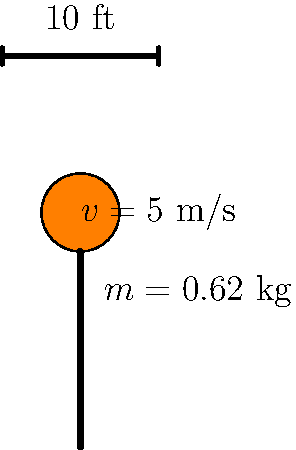During a basketball game in Evansville, a player dunks the ball straight down into the hoop. The ball has a mass of 0.62 kg and is moving at 5 m/s just before it reaches the rim. If the ball comes to a complete stop in 0.1 seconds after hitting the rim, what is the average force applied to the ball by the rim? Let's approach this step-by-step using the information given and the principles of physics:

1) First, we need to recall the relationship between force, mass, and acceleration. This is given by Newton's Second Law:

   $$F = ma$$

   where $F$ is force, $m$ is mass, and $a$ is acceleration.

2) We're given the mass of the ball: $m = 0.62$ kg

3) We need to find the acceleration. We can do this using the equation:

   $$a = \frac{\Delta v}{\Delta t}$$

   where $\Delta v$ is the change in velocity and $\Delta t$ is the time interval.

4) Initial velocity $v_i = 5$ m/s (downward)
   Final velocity $v_f = 0$ m/s (the ball stops)
   Time interval $\Delta t = 0.1$ s

5) Calculating the acceleration:

   $$a = \frac{v_f - v_i}{\Delta t} = \frac{0 - 5}{0.1} = -50 \text{ m/s}^2$$

   The negative sign indicates the acceleration is in the opposite direction of the initial velocity.

6) Now we can calculate the force:

   $$F = ma = 0.62 \times (-50) = -31 \text{ N}$$

7) The negative sign indicates the force is upward, opposing the downward motion of the ball.

8) We're asked for the average force, which is the absolute value of this force.

Therefore, the average force applied to the ball by the rim is 31 N.
Answer: 31 N 